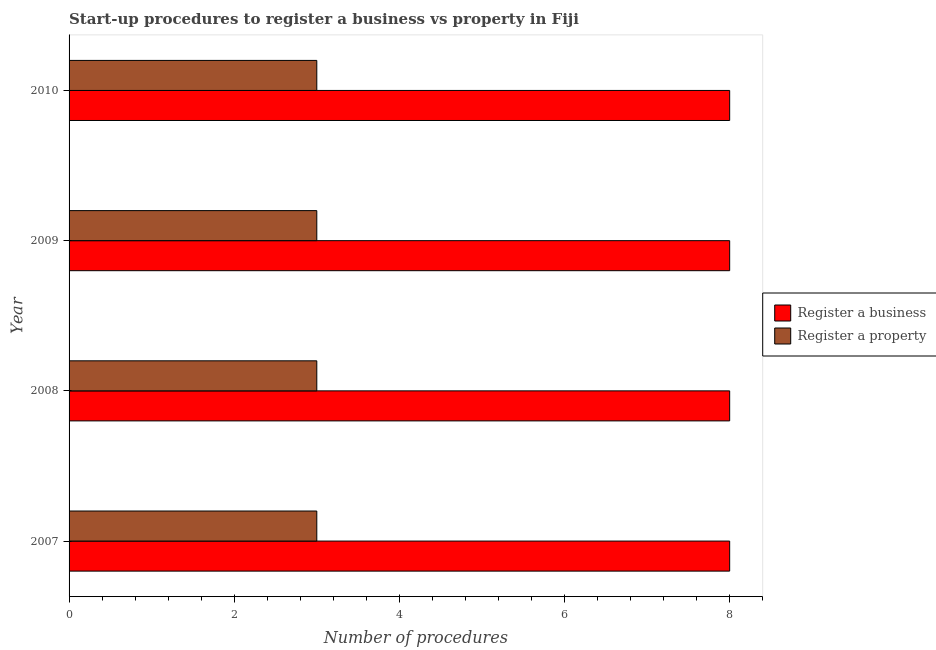How many different coloured bars are there?
Provide a succinct answer. 2. How many groups of bars are there?
Offer a terse response. 4. Are the number of bars per tick equal to the number of legend labels?
Ensure brevity in your answer.  Yes. Are the number of bars on each tick of the Y-axis equal?
Your answer should be very brief. Yes. In how many cases, is the number of bars for a given year not equal to the number of legend labels?
Ensure brevity in your answer.  0. What is the number of procedures to register a property in 2007?
Your answer should be very brief. 3. Across all years, what is the maximum number of procedures to register a business?
Your response must be concise. 8. Across all years, what is the minimum number of procedures to register a business?
Make the answer very short. 8. What is the total number of procedures to register a property in the graph?
Offer a very short reply. 12. What is the difference between the number of procedures to register a property in 2007 and that in 2008?
Offer a terse response. 0. What is the difference between the number of procedures to register a property in 2009 and the number of procedures to register a business in 2010?
Provide a short and direct response. -5. What is the average number of procedures to register a property per year?
Ensure brevity in your answer.  3. In the year 2007, what is the difference between the number of procedures to register a property and number of procedures to register a business?
Provide a succinct answer. -5. Is the number of procedures to register a business in 2007 less than that in 2010?
Offer a very short reply. No. What is the difference between the highest and the second highest number of procedures to register a business?
Offer a terse response. 0. In how many years, is the number of procedures to register a property greater than the average number of procedures to register a property taken over all years?
Ensure brevity in your answer.  0. What does the 2nd bar from the top in 2009 represents?
Offer a very short reply. Register a business. What does the 1st bar from the bottom in 2009 represents?
Provide a succinct answer. Register a business. How many bars are there?
Ensure brevity in your answer.  8. How many years are there in the graph?
Keep it short and to the point. 4. What is the difference between two consecutive major ticks on the X-axis?
Your answer should be compact. 2. Where does the legend appear in the graph?
Offer a terse response. Center right. How many legend labels are there?
Make the answer very short. 2. How are the legend labels stacked?
Your answer should be compact. Vertical. What is the title of the graph?
Provide a succinct answer. Start-up procedures to register a business vs property in Fiji. Does "Working capital" appear as one of the legend labels in the graph?
Give a very brief answer. No. What is the label or title of the X-axis?
Offer a very short reply. Number of procedures. What is the label or title of the Y-axis?
Your response must be concise. Year. What is the Number of procedures in Register a business in 2008?
Offer a very short reply. 8. What is the Number of procedures in Register a property in 2008?
Provide a short and direct response. 3. What is the Number of procedures of Register a business in 2009?
Provide a succinct answer. 8. What is the Number of procedures in Register a business in 2010?
Your answer should be very brief. 8. What is the Number of procedures in Register a property in 2010?
Provide a short and direct response. 3. Across all years, what is the minimum Number of procedures of Register a business?
Ensure brevity in your answer.  8. What is the total Number of procedures in Register a business in the graph?
Provide a short and direct response. 32. What is the difference between the Number of procedures of Register a business in 2007 and that in 2008?
Your answer should be very brief. 0. What is the difference between the Number of procedures of Register a business in 2008 and that in 2009?
Your response must be concise. 0. What is the difference between the Number of procedures in Register a property in 2008 and that in 2009?
Your answer should be compact. 0. What is the difference between the Number of procedures of Register a business in 2009 and that in 2010?
Offer a very short reply. 0. What is the difference between the Number of procedures in Register a property in 2009 and that in 2010?
Your response must be concise. 0. What is the difference between the Number of procedures of Register a business in 2007 and the Number of procedures of Register a property in 2009?
Your answer should be very brief. 5. What is the difference between the Number of procedures of Register a business in 2007 and the Number of procedures of Register a property in 2010?
Ensure brevity in your answer.  5. What is the average Number of procedures in Register a property per year?
Ensure brevity in your answer.  3. In the year 2007, what is the difference between the Number of procedures in Register a business and Number of procedures in Register a property?
Provide a succinct answer. 5. In the year 2008, what is the difference between the Number of procedures in Register a business and Number of procedures in Register a property?
Give a very brief answer. 5. What is the ratio of the Number of procedures of Register a business in 2007 to that in 2009?
Ensure brevity in your answer.  1. What is the ratio of the Number of procedures of Register a property in 2007 to that in 2009?
Your answer should be compact. 1. What is the ratio of the Number of procedures in Register a business in 2007 to that in 2010?
Offer a terse response. 1. What is the ratio of the Number of procedures in Register a business in 2008 to that in 2009?
Your answer should be very brief. 1. What is the ratio of the Number of procedures of Register a property in 2009 to that in 2010?
Your response must be concise. 1. What is the difference between the highest and the lowest Number of procedures in Register a business?
Offer a terse response. 0. What is the difference between the highest and the lowest Number of procedures in Register a property?
Provide a short and direct response. 0. 